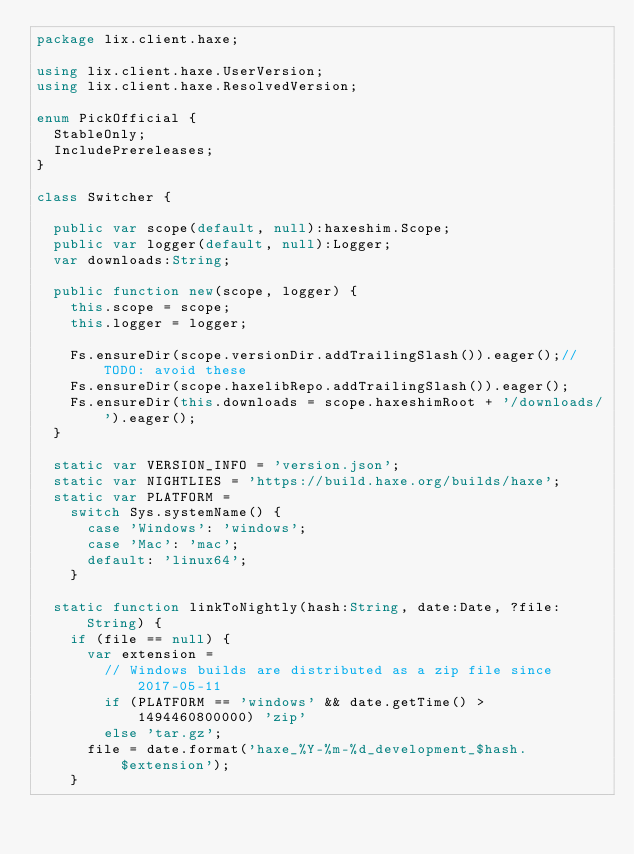Convert code to text. <code><loc_0><loc_0><loc_500><loc_500><_Haxe_>package lix.client.haxe;

using lix.client.haxe.UserVersion;
using lix.client.haxe.ResolvedVersion;

enum PickOfficial {
  StableOnly;
  IncludePrereleases;
}

class Switcher {

  public var scope(default, null):haxeshim.Scope;
  public var logger(default, null):Logger;
  var downloads:String;

  public function new(scope, logger) {
    this.scope = scope;
    this.logger = logger;

    Fs.ensureDir(scope.versionDir.addTrailingSlash()).eager();//TODO: avoid these
    Fs.ensureDir(scope.haxelibRepo.addTrailingSlash()).eager();
    Fs.ensureDir(this.downloads = scope.haxeshimRoot + '/downloads/').eager();
  }

  static var VERSION_INFO = 'version.json';
  static var NIGHTLIES = 'https://build.haxe.org/builds/haxe';
  static var PLATFORM =
    switch Sys.systemName() {
      case 'Windows': 'windows';
      case 'Mac': 'mac';
      default: 'linux64';
    }

  static function linkToNightly(hash:String, date:Date, ?file:String) {
    if (file == null) {
      var extension =
        // Windows builds are distributed as a zip file since 2017-05-11
        if (PLATFORM == 'windows' && date.getTime() > 1494460800000) 'zip'
        else 'tar.gz';
      file = date.format('haxe_%Y-%m-%d_development_$hash.$extension');
    }</code> 